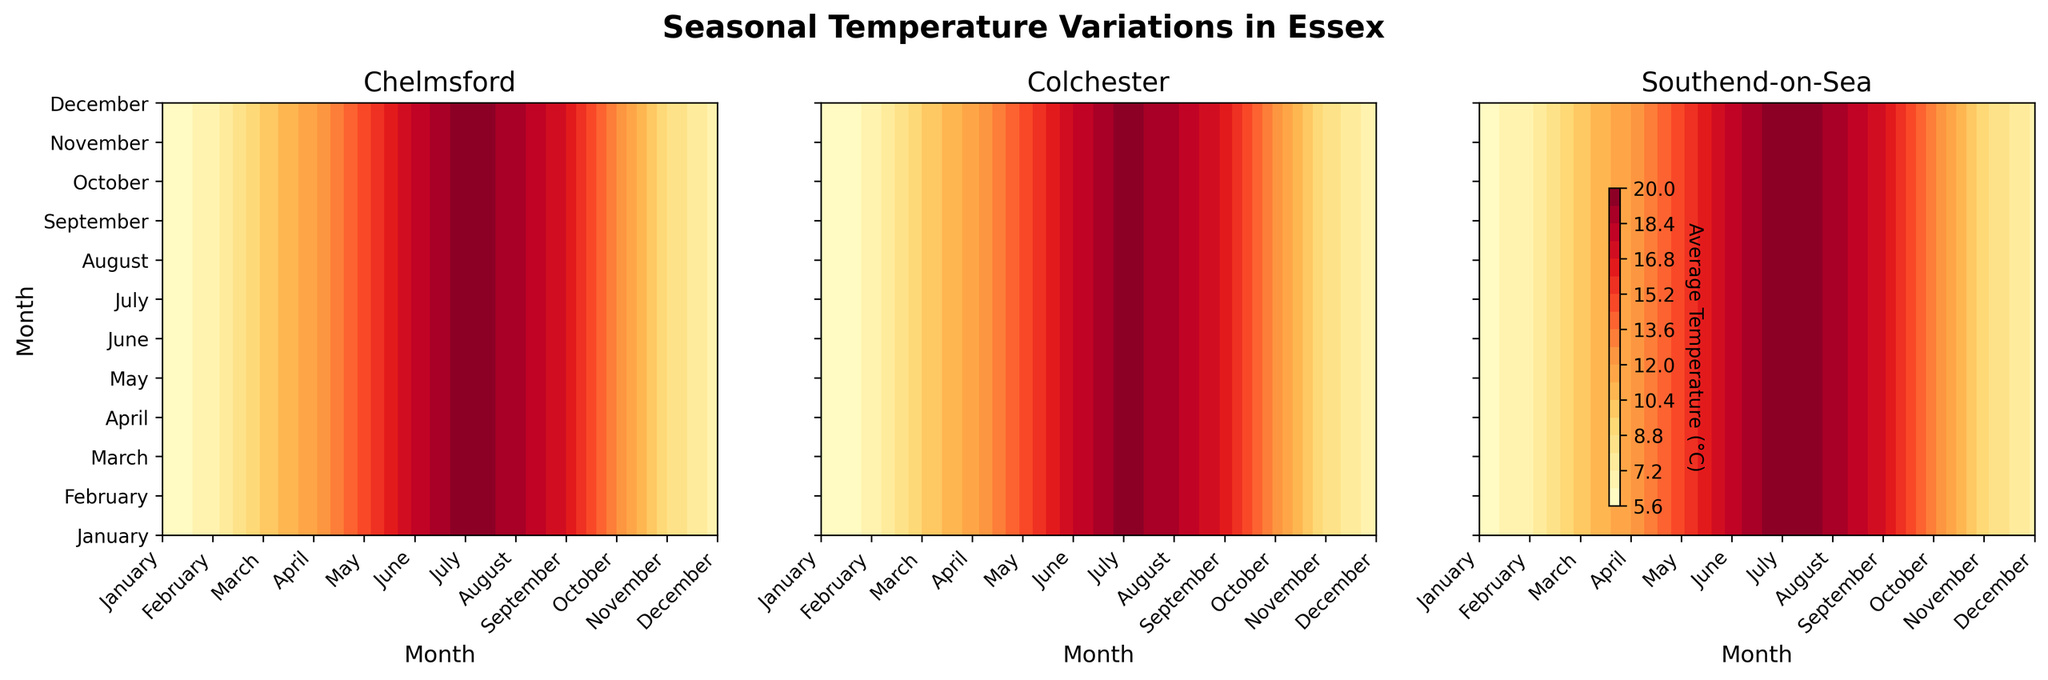What is the title of the figure? The title is usually located at the top of the figure, and it provides a summary of what the figure is about. The title of this figure reads "Seasonal Temperature Variations in Essex."
Answer: Seasonal Temperature Variations in Essex Which region shows the highest average temperature in July? By locating the subplots for Chelmsford, Colchester, and Southend-on-Sea and checking the contour colors for July, we can see that Southend-on-Sea has the highest temperature.
Answer: Southend-on-Sea Which month has the lowest average temperature in Colchester? By examining the Colchester subplot and looking for the month with the darkest shade (representing the lowest temperature) on the contour map, January displays the lowest temperature.
Answer: January How does the seasonal temperature variation in Chelmsford compare to Southend-on-Sea for June? By comparing the contour colors representing June in both Chelmsford and Southend-on-Sea subplots, Chelmsford shows a slightly lower temperature.
Answer: Chelmsford is lower What is the temperature range in Chelmsford throughout the year? Chelmsford temperatures range from 5°C in January to 19°C in July. This range can be determined by checking the contour map color gradient for the lowest and highest temperatures.
Answer: 5°C to 19°C In which region does November have similar temperatures to October in Chelmsford? By comparing the November temperature in all regions with the October temperature in Chelmsford, Colchester shows a similar temperature profile.
Answer: Colchester What temperature range is seen in Southend-on-Sea during the winter months (December to February)? For Southend-on-Sea, checking December, January, and February collectively, we see a temperature range between 6°C and 7°C.
Answer: 6°C to 7°C Which month has temperatures equal to Southend-on-Sea's February in Colchester? Southend-on-Sea shows 7°C in February. Checking Colchester's months, May has a comparable temperature profile.
Answer: May Is there a month where all regions show an equal average temperature? By cross-referencing all months across all regions, there is no single month where all regions match in temperature. The contours indicate variability.
Answer: No Which region shows the most gradual slope in temperature change from April to May? By comparing the contour gradients from April to May, Chelmsford shows the most gradual change, which can be observed by the smoother color gradient in that period.
Answer: Chelmsford 